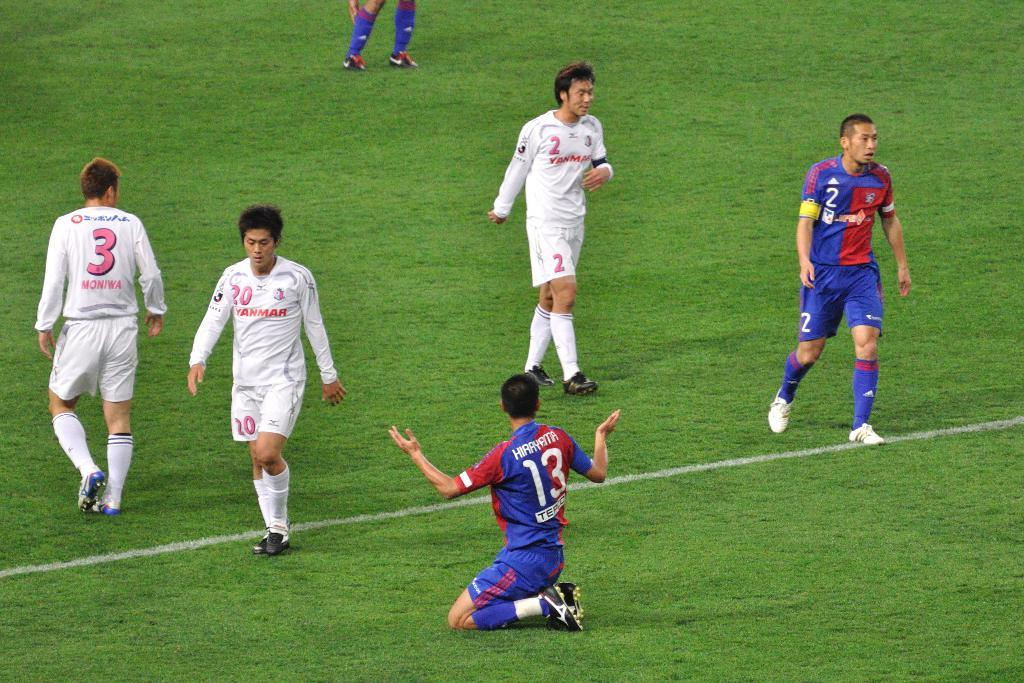What can be seen in the image? There are players in the image. Where are the players located? The players are on the ground. What type of crayon is being used by the players in the image? There is no crayon present in the image; the players are on the ground, and no crayons are mentioned in the facts provided. 